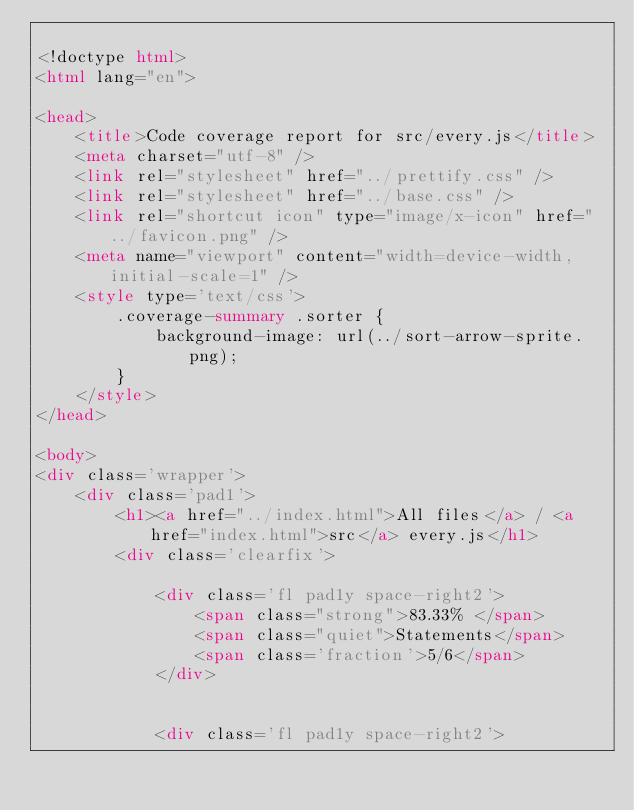<code> <loc_0><loc_0><loc_500><loc_500><_HTML_>
<!doctype html>
<html lang="en">

<head>
    <title>Code coverage report for src/every.js</title>
    <meta charset="utf-8" />
    <link rel="stylesheet" href="../prettify.css" />
    <link rel="stylesheet" href="../base.css" />
    <link rel="shortcut icon" type="image/x-icon" href="../favicon.png" />
    <meta name="viewport" content="width=device-width, initial-scale=1" />
    <style type='text/css'>
        .coverage-summary .sorter {
            background-image: url(../sort-arrow-sprite.png);
        }
    </style>
</head>
    
<body>
<div class='wrapper'>
    <div class='pad1'>
        <h1><a href="../index.html">All files</a> / <a href="index.html">src</a> every.js</h1>
        <div class='clearfix'>
            
            <div class='fl pad1y space-right2'>
                <span class="strong">83.33% </span>
                <span class="quiet">Statements</span>
                <span class='fraction'>5/6</span>
            </div>
        
            
            <div class='fl pad1y space-right2'></code> 